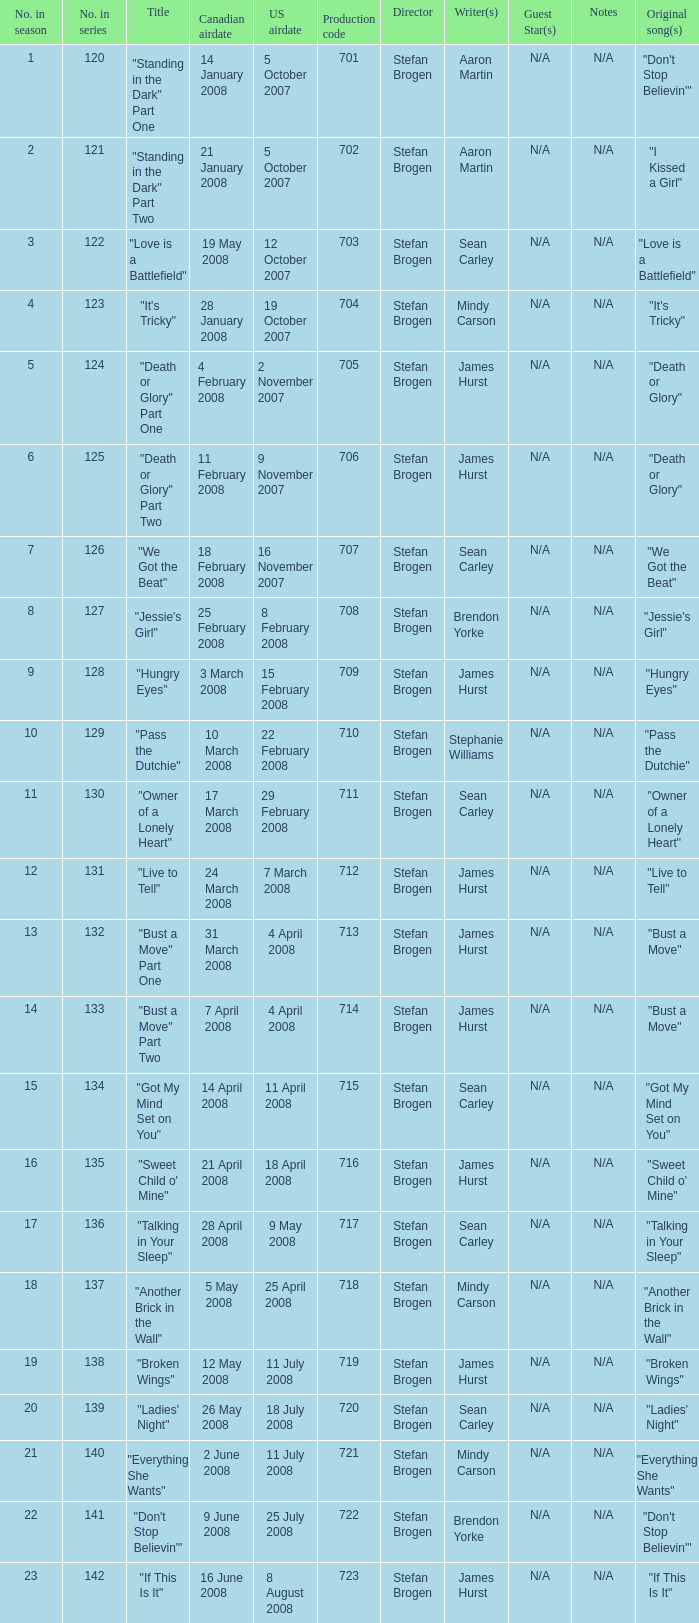The U.S. airdate of 8 august 2008 also had canadian airdates of what? 16 June 2008. 